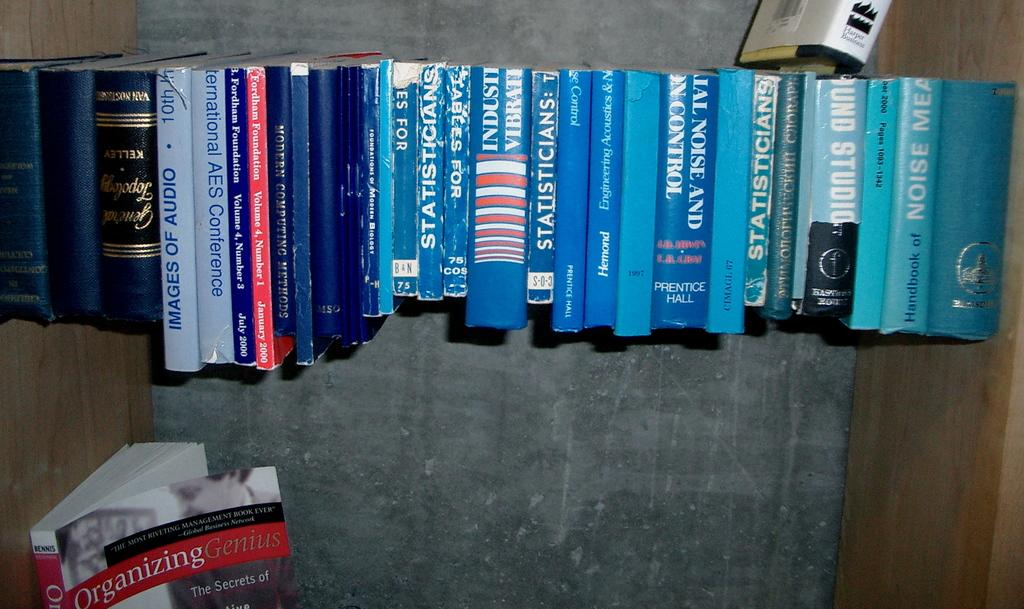Provide a one-sentence caption for the provided image. a book about statisticians next to other books. 